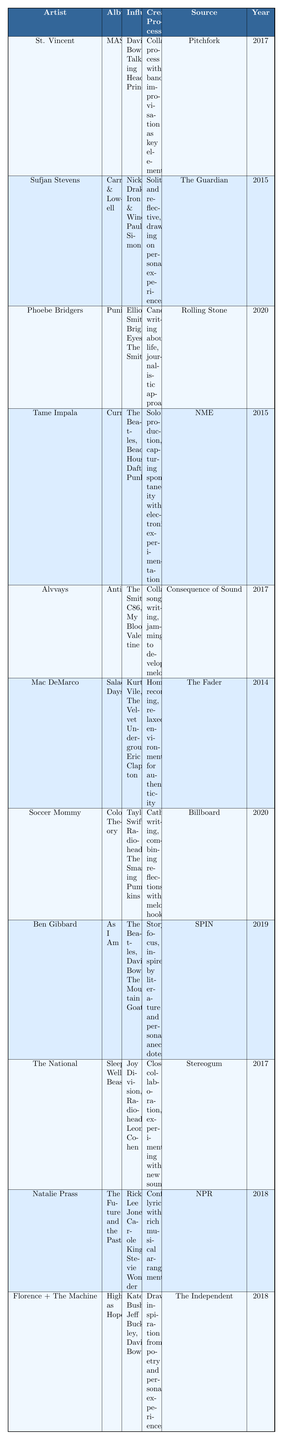What album did Phoebe Bridgers release in 2020? The table shows that Phoebe Bridgers released the album "Punisher" in the year 2020.
Answer: Punisher Who interviewed Mac DeMarco about his creative process? According to the table, Mac DeMarco's creative process was discussed in an interview conducted by The Fader.
Answer: The Fader Which artist's influences include Taylor Swift and Radiohead? The table lists Soccer Mommy as the artist whose influences include Taylor Swift and Radiohead.
Answer: Soccer Mommy How many artists have David Bowie listed as an influence? From the table, David Bowie is listed as an influence for St. Vincent, Ben Gibbard, and Florence + The Machine, totaling three artists.
Answer: 3 Did Sufjan Stevens have a collaborative creative process for his album? The table indicates that Sufjan Stevens has a solitary and reflective creative process, so his approach is not collaborative.
Answer: No Which artist produced and wrote all tracks themselves? The table mentions that Kevin Parker of Tame Impala produces and writes everything himself.
Answer: Tame Impala What is the main theme of Soccer Mommy's music according to her interview? The table states that Soccer Mommy writes music as a means of catharsis, focusing on thoughtful reflections and relatable themes.
Answer: Catharsis What year did Alvvays release their album "Antisocialites"? The table details that Alvvays released "Antisocialites" in the year 2017.
Answer: 2017 Which two artists share the same influence from The Beatles? The table reveals that both Tame Impala and Ben Gibbard have The Beatles listed as an influence.
Answer: Tame Impala and Ben Gibbard What is the common theme found in the creative processes of both Natalie Prass and Florence + The Machine? Both artists draw inspiration from personal experiences and confessional lyrics, focusing on emotional and relatable themes in their music as per the table.
Answer: Personal experiences and confessional lyrics How many albums were released by artists in the table between 2015 and 2018? The table records albums by Sufjan Stevens (2015), Tame Impala (2015), Alvvays (2017), St. Vincent (2017), The National (2017), Natalie Prass (2018), and Florence + The Machine (2018), totaling seven albums.
Answer: 7 What distinct creative process does St. Vincent employ according to the interview? St. Vincent employs a collaborative creative process with her band, emphasizing improvisation while creating in the studio, as noted in the table.
Answer: Collaborative process with improvisation 